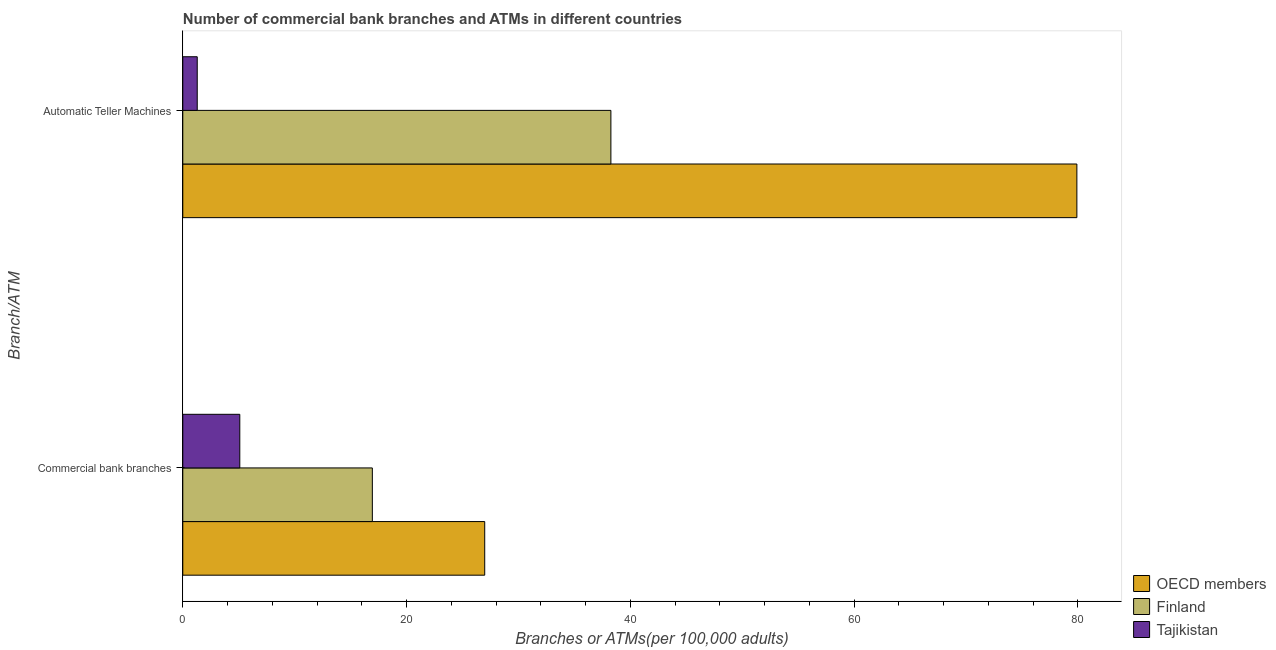How many groups of bars are there?
Your answer should be very brief. 2. How many bars are there on the 2nd tick from the bottom?
Offer a terse response. 3. What is the label of the 2nd group of bars from the top?
Your answer should be very brief. Commercial bank branches. What is the number of atms in Tajikistan?
Make the answer very short. 1.29. Across all countries, what is the maximum number of atms?
Your answer should be very brief. 79.91. Across all countries, what is the minimum number of atms?
Your answer should be compact. 1.29. In which country was the number of commercal bank branches maximum?
Offer a terse response. OECD members. In which country was the number of atms minimum?
Offer a terse response. Tajikistan. What is the total number of commercal bank branches in the graph?
Your response must be concise. 49.02. What is the difference between the number of commercal bank branches in OECD members and that in Finland?
Provide a succinct answer. 10.04. What is the difference between the number of commercal bank branches in Finland and the number of atms in OECD members?
Offer a very short reply. -62.97. What is the average number of commercal bank branches per country?
Keep it short and to the point. 16.34. What is the difference between the number of atms and number of commercal bank branches in Finland?
Offer a terse response. 21.32. What is the ratio of the number of atms in OECD members to that in Tajikistan?
Provide a short and direct response. 61.9. In how many countries, is the number of atms greater than the average number of atms taken over all countries?
Keep it short and to the point. 1. What does the 3rd bar from the top in Automatic Teller Machines represents?
Make the answer very short. OECD members. What does the 2nd bar from the bottom in Automatic Teller Machines represents?
Your answer should be very brief. Finland. Are all the bars in the graph horizontal?
Provide a short and direct response. Yes. How many countries are there in the graph?
Ensure brevity in your answer.  3. What is the difference between two consecutive major ticks on the X-axis?
Keep it short and to the point. 20. Does the graph contain grids?
Your answer should be compact. No. Where does the legend appear in the graph?
Provide a short and direct response. Bottom right. How are the legend labels stacked?
Offer a very short reply. Vertical. What is the title of the graph?
Offer a terse response. Number of commercial bank branches and ATMs in different countries. What is the label or title of the X-axis?
Make the answer very short. Branches or ATMs(per 100,0 adults). What is the label or title of the Y-axis?
Make the answer very short. Branch/ATM. What is the Branches or ATMs(per 100,000 adults) in OECD members in Commercial bank branches?
Offer a very short reply. 26.99. What is the Branches or ATMs(per 100,000 adults) of Finland in Commercial bank branches?
Keep it short and to the point. 16.94. What is the Branches or ATMs(per 100,000 adults) of Tajikistan in Commercial bank branches?
Ensure brevity in your answer.  5.09. What is the Branches or ATMs(per 100,000 adults) of OECD members in Automatic Teller Machines?
Your response must be concise. 79.91. What is the Branches or ATMs(per 100,000 adults) of Finland in Automatic Teller Machines?
Keep it short and to the point. 38.26. What is the Branches or ATMs(per 100,000 adults) in Tajikistan in Automatic Teller Machines?
Provide a short and direct response. 1.29. Across all Branch/ATM, what is the maximum Branches or ATMs(per 100,000 adults) of OECD members?
Your response must be concise. 79.91. Across all Branch/ATM, what is the maximum Branches or ATMs(per 100,000 adults) in Finland?
Offer a terse response. 38.26. Across all Branch/ATM, what is the maximum Branches or ATMs(per 100,000 adults) in Tajikistan?
Provide a succinct answer. 5.09. Across all Branch/ATM, what is the minimum Branches or ATMs(per 100,000 adults) in OECD members?
Give a very brief answer. 26.99. Across all Branch/ATM, what is the minimum Branches or ATMs(per 100,000 adults) in Finland?
Make the answer very short. 16.94. Across all Branch/ATM, what is the minimum Branches or ATMs(per 100,000 adults) of Tajikistan?
Your answer should be compact. 1.29. What is the total Branches or ATMs(per 100,000 adults) in OECD members in the graph?
Your answer should be compact. 106.9. What is the total Branches or ATMs(per 100,000 adults) of Finland in the graph?
Provide a short and direct response. 55.2. What is the total Branches or ATMs(per 100,000 adults) in Tajikistan in the graph?
Provide a short and direct response. 6.39. What is the difference between the Branches or ATMs(per 100,000 adults) in OECD members in Commercial bank branches and that in Automatic Teller Machines?
Give a very brief answer. -52.93. What is the difference between the Branches or ATMs(per 100,000 adults) in Finland in Commercial bank branches and that in Automatic Teller Machines?
Offer a terse response. -21.32. What is the difference between the Branches or ATMs(per 100,000 adults) of Tajikistan in Commercial bank branches and that in Automatic Teller Machines?
Offer a very short reply. 3.8. What is the difference between the Branches or ATMs(per 100,000 adults) in OECD members in Commercial bank branches and the Branches or ATMs(per 100,000 adults) in Finland in Automatic Teller Machines?
Provide a succinct answer. -11.28. What is the difference between the Branches or ATMs(per 100,000 adults) of OECD members in Commercial bank branches and the Branches or ATMs(per 100,000 adults) of Tajikistan in Automatic Teller Machines?
Keep it short and to the point. 25.69. What is the difference between the Branches or ATMs(per 100,000 adults) of Finland in Commercial bank branches and the Branches or ATMs(per 100,000 adults) of Tajikistan in Automatic Teller Machines?
Provide a short and direct response. 15.65. What is the average Branches or ATMs(per 100,000 adults) in OECD members per Branch/ATM?
Provide a short and direct response. 53.45. What is the average Branches or ATMs(per 100,000 adults) of Finland per Branch/ATM?
Give a very brief answer. 27.6. What is the average Branches or ATMs(per 100,000 adults) in Tajikistan per Branch/ATM?
Your answer should be compact. 3.19. What is the difference between the Branches or ATMs(per 100,000 adults) of OECD members and Branches or ATMs(per 100,000 adults) of Finland in Commercial bank branches?
Offer a very short reply. 10.04. What is the difference between the Branches or ATMs(per 100,000 adults) of OECD members and Branches or ATMs(per 100,000 adults) of Tajikistan in Commercial bank branches?
Give a very brief answer. 21.89. What is the difference between the Branches or ATMs(per 100,000 adults) of Finland and Branches or ATMs(per 100,000 adults) of Tajikistan in Commercial bank branches?
Keep it short and to the point. 11.85. What is the difference between the Branches or ATMs(per 100,000 adults) in OECD members and Branches or ATMs(per 100,000 adults) in Finland in Automatic Teller Machines?
Ensure brevity in your answer.  41.65. What is the difference between the Branches or ATMs(per 100,000 adults) in OECD members and Branches or ATMs(per 100,000 adults) in Tajikistan in Automatic Teller Machines?
Ensure brevity in your answer.  78.62. What is the difference between the Branches or ATMs(per 100,000 adults) in Finland and Branches or ATMs(per 100,000 adults) in Tajikistan in Automatic Teller Machines?
Make the answer very short. 36.97. What is the ratio of the Branches or ATMs(per 100,000 adults) of OECD members in Commercial bank branches to that in Automatic Teller Machines?
Offer a terse response. 0.34. What is the ratio of the Branches or ATMs(per 100,000 adults) in Finland in Commercial bank branches to that in Automatic Teller Machines?
Offer a terse response. 0.44. What is the ratio of the Branches or ATMs(per 100,000 adults) in Tajikistan in Commercial bank branches to that in Automatic Teller Machines?
Offer a terse response. 3.95. What is the difference between the highest and the second highest Branches or ATMs(per 100,000 adults) in OECD members?
Provide a succinct answer. 52.93. What is the difference between the highest and the second highest Branches or ATMs(per 100,000 adults) of Finland?
Offer a very short reply. 21.32. What is the difference between the highest and the second highest Branches or ATMs(per 100,000 adults) of Tajikistan?
Your answer should be compact. 3.8. What is the difference between the highest and the lowest Branches or ATMs(per 100,000 adults) in OECD members?
Your response must be concise. 52.93. What is the difference between the highest and the lowest Branches or ATMs(per 100,000 adults) in Finland?
Keep it short and to the point. 21.32. What is the difference between the highest and the lowest Branches or ATMs(per 100,000 adults) of Tajikistan?
Give a very brief answer. 3.8. 